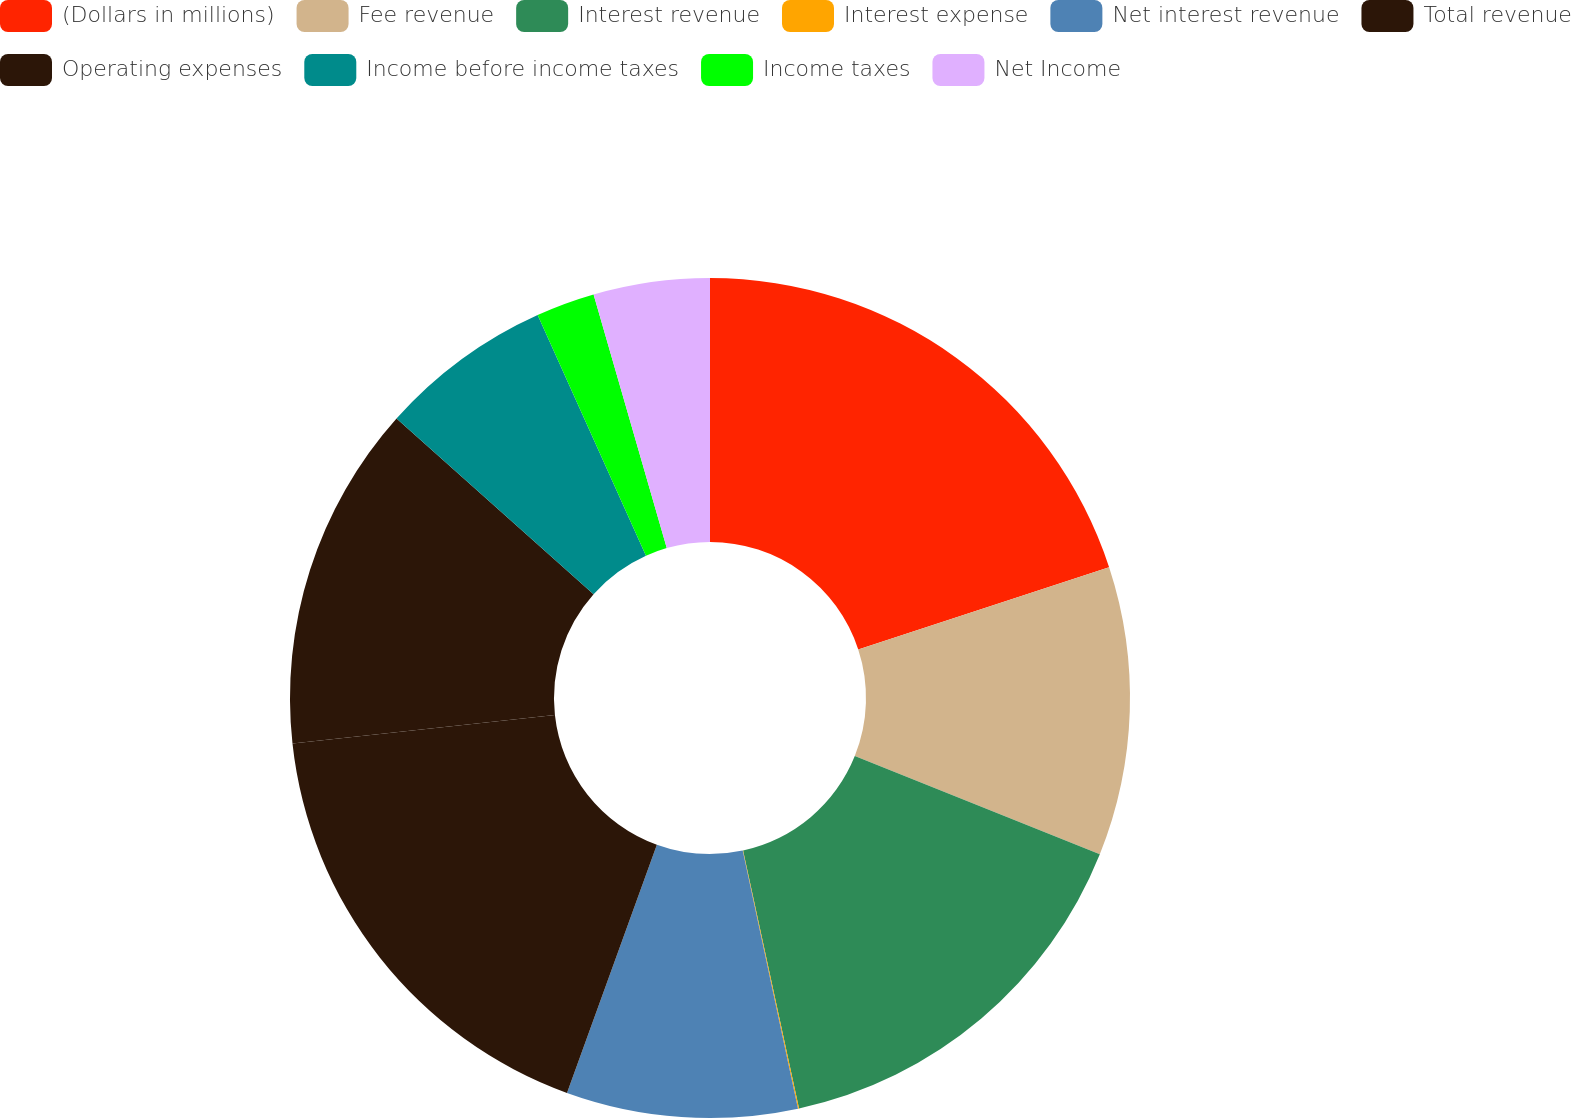Convert chart to OTSL. <chart><loc_0><loc_0><loc_500><loc_500><pie_chart><fcel>(Dollars in millions)<fcel>Fee revenue<fcel>Interest revenue<fcel>Interest expense<fcel>Net interest revenue<fcel>Total revenue<fcel>Operating expenses<fcel>Income before income taxes<fcel>Income taxes<fcel>Net Income<nl><fcel>19.96%<fcel>11.11%<fcel>15.53%<fcel>0.04%<fcel>8.89%<fcel>17.74%<fcel>13.32%<fcel>6.68%<fcel>2.26%<fcel>4.47%<nl></chart> 